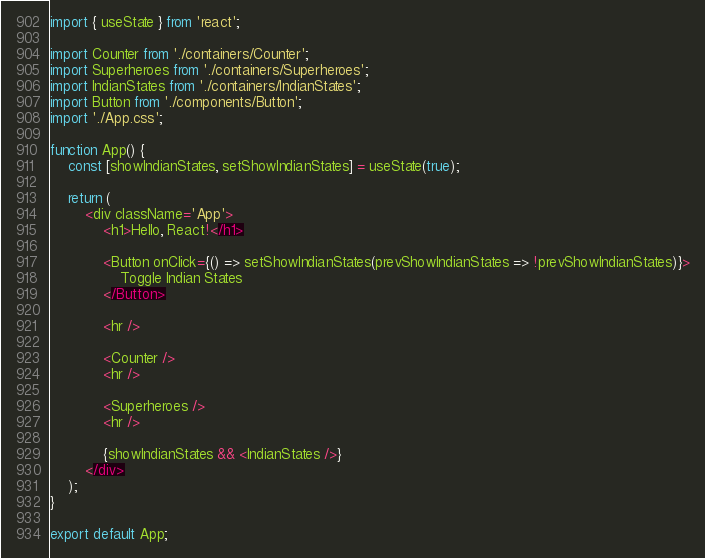<code> <loc_0><loc_0><loc_500><loc_500><_JavaScript_>import { useState } from 'react';

import Counter from './containers/Counter';
import Superheroes from './containers/Superheroes';
import IndianStates from './containers/IndianStates';
import Button from './components/Button';
import './App.css';

function App() {
	const [showIndianStates, setShowIndianStates] = useState(true);

	return (
		<div className='App'>
			<h1>Hello, React!</h1>

			<Button onClick={() => setShowIndianStates(prevShowIndianStates => !prevShowIndianStates)}>
				Toggle Indian States
			</Button>

			<hr />

			<Counter />
			<hr />

			<Superheroes />
			<hr />

			{showIndianStates && <IndianStates />}
		</div>
	);
}

export default App;
</code> 